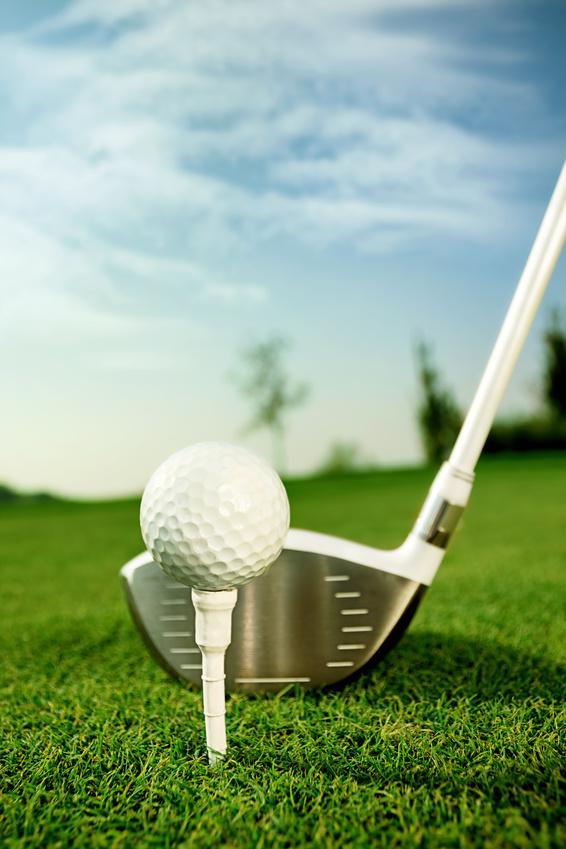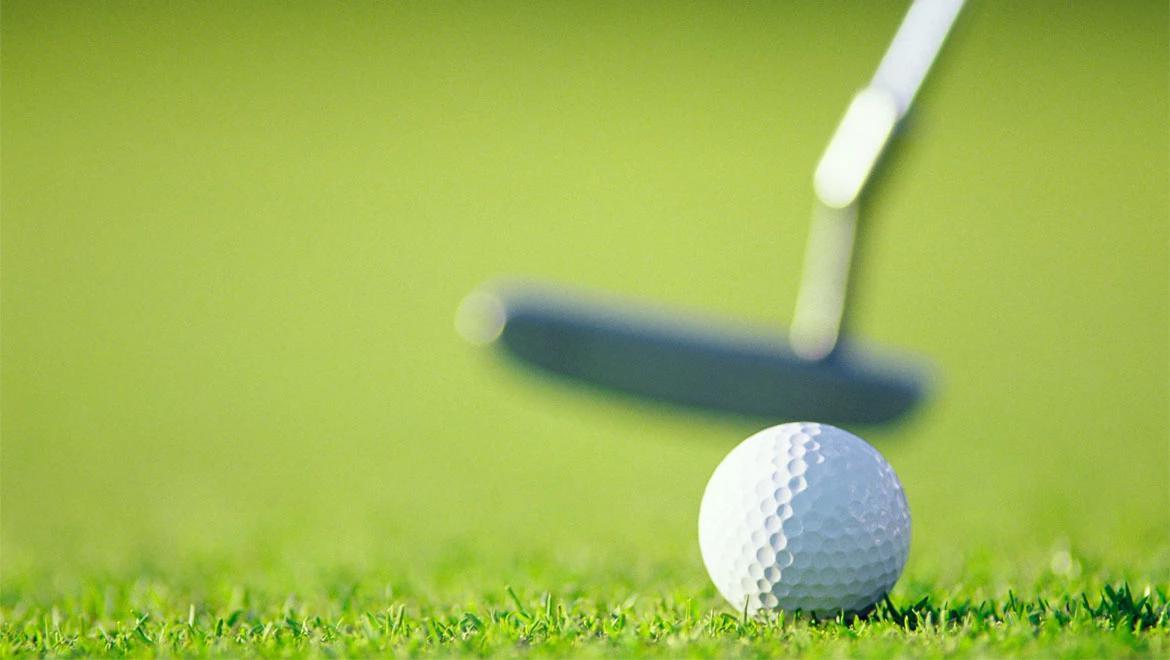The first image is the image on the left, the second image is the image on the right. Given the left and right images, does the statement "Golf clubs are near the ball in both images." hold true? Answer yes or no. Yes. The first image is the image on the left, the second image is the image on the right. For the images displayed, is the sentence "Both golf balls have a golf club next to them." factually correct? Answer yes or no. Yes. 